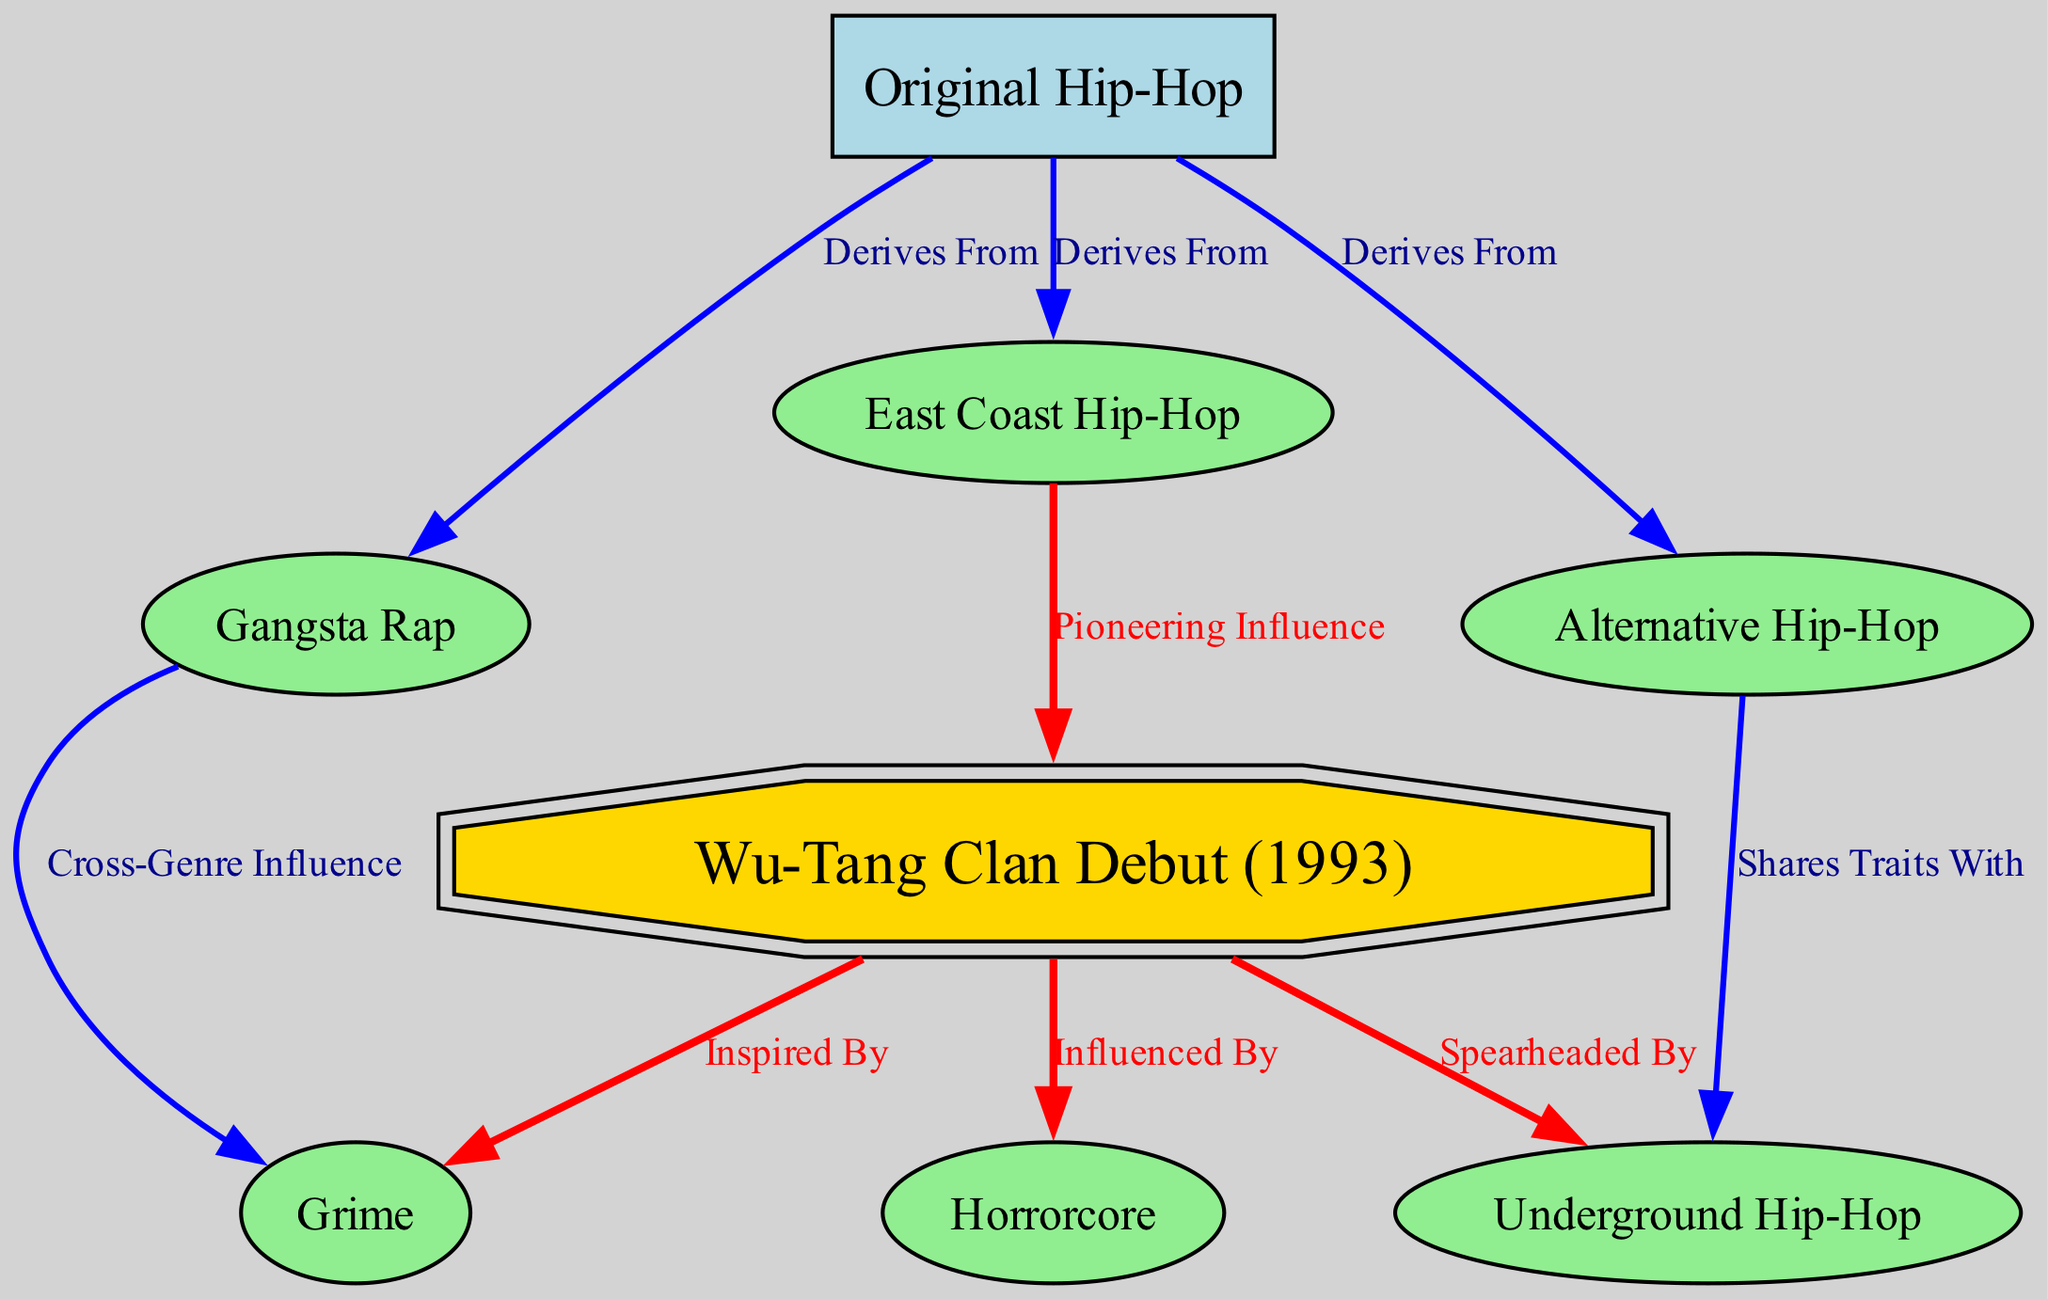What type of node represents "Wu-Tang Clan Debut (1993)" in the diagram? The node for "Wu-Tang Clan Debut (1993)" is shaped as a double octagon, which is specifically used to indicate its importance as a pioneering influence.
Answer: doubleoctagon How many edges are connected to "Original Hip-Hop"? The "Original Hip-Hop" node has three outgoing edges connecting to "East Coast Hip-Hop," "Gangsta Rap," and "Alternative Hip-Hop," indicating its derivation from these subgenres.
Answer: 3 Which subgenre is strongly influenced by "Wu-Tang Clan Debut (1993)"? "Underground Hip-Hop" is directly connected to "Wu-Tang Clan Debut (1993)" through an edge labeled "Spearheaded By", showing its strong influence.
Answer: Underground Hip-Hop What color is used to represent the "Gangsta Rap" node? The "Gangsta Rap" node is filled with light green color, which represents its designation compared to other types in the diagram.
Answer: lightgreen Which two subgenres share traits according to the diagram? "Alternative Hip-Hop" and "Underground Hip-Hop" are connected through an edge labeled "Shares Traits With"; thus, they share certain characteristics.
Answer: Alternative Hip-Hop, Underground Hip-Hop What is the relationship between "Gangsta Rap" and "Grime"? The "Gangsta Rap" node is connected to the "Grime" node with an edge labeled "Cross-Genre Influence," indicating a shared influence across genres.
Answer: Cross-Genre Influence How many total nodes are illustrated in the diagram? The diagram features a total of eight nodes, representing various hip-hop subgenres and influences, which include "Original Hip-Hop," "Wu-Tang Clan Debut," "East Coast Hip-Hop," "Gangsta Rap," "Alternative Hip-Hop," "Underground Hip-Hop," "Grime," and "Horrorcore."
Answer: 8 What type of influence does "Grime" have according to the diagram? "Grime" is shown to be influenced by "Wu-Tang Clan Debut (1993)" as indicated by the edge labeled "Inspired By".
Answer: Inspired By What do the red edges in the diagram signify? The edges connecting to and from the "Wu-Tang Clan Debut (1993)" node are colored red, indicating their significance in influencing various other subgenres in the diagram.
Answer: Significance 